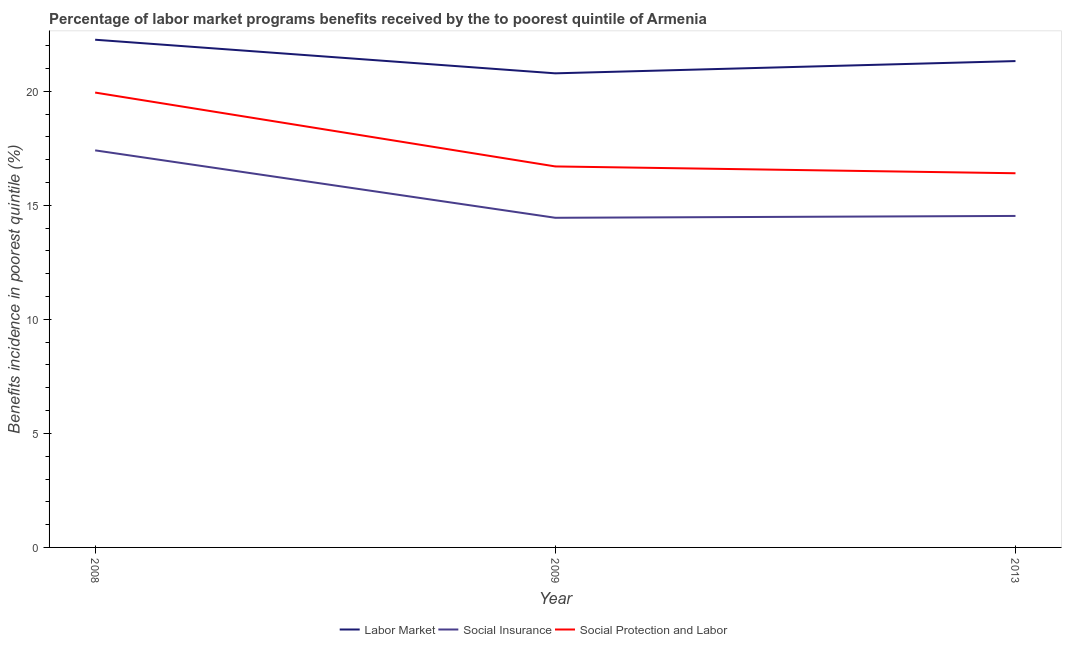How many different coloured lines are there?
Your response must be concise. 3. Does the line corresponding to percentage of benefits received due to social insurance programs intersect with the line corresponding to percentage of benefits received due to labor market programs?
Give a very brief answer. No. Is the number of lines equal to the number of legend labels?
Your answer should be very brief. Yes. What is the percentage of benefits received due to social insurance programs in 2013?
Your answer should be compact. 14.54. Across all years, what is the maximum percentage of benefits received due to labor market programs?
Your answer should be compact. 22.26. Across all years, what is the minimum percentage of benefits received due to social protection programs?
Offer a terse response. 16.41. What is the total percentage of benefits received due to social insurance programs in the graph?
Provide a short and direct response. 46.4. What is the difference between the percentage of benefits received due to social insurance programs in 2009 and that in 2013?
Ensure brevity in your answer.  -0.08. What is the difference between the percentage of benefits received due to social protection programs in 2008 and the percentage of benefits received due to social insurance programs in 2009?
Ensure brevity in your answer.  5.49. What is the average percentage of benefits received due to social protection programs per year?
Provide a short and direct response. 17.69. In the year 2013, what is the difference between the percentage of benefits received due to social protection programs and percentage of benefits received due to social insurance programs?
Offer a very short reply. 1.87. In how many years, is the percentage of benefits received due to labor market programs greater than 4 %?
Your response must be concise. 3. What is the ratio of the percentage of benefits received due to social protection programs in 2008 to that in 2009?
Ensure brevity in your answer.  1.19. Is the difference between the percentage of benefits received due to social insurance programs in 2009 and 2013 greater than the difference between the percentage of benefits received due to labor market programs in 2009 and 2013?
Keep it short and to the point. Yes. What is the difference between the highest and the second highest percentage of benefits received due to social protection programs?
Ensure brevity in your answer.  3.24. What is the difference between the highest and the lowest percentage of benefits received due to social insurance programs?
Give a very brief answer. 2.96. Is the sum of the percentage of benefits received due to social insurance programs in 2009 and 2013 greater than the maximum percentage of benefits received due to social protection programs across all years?
Provide a succinct answer. Yes. Is it the case that in every year, the sum of the percentage of benefits received due to labor market programs and percentage of benefits received due to social insurance programs is greater than the percentage of benefits received due to social protection programs?
Your answer should be very brief. Yes. Does the percentage of benefits received due to labor market programs monotonically increase over the years?
Your response must be concise. No. How many years are there in the graph?
Ensure brevity in your answer.  3. Does the graph contain any zero values?
Ensure brevity in your answer.  No. Where does the legend appear in the graph?
Offer a very short reply. Bottom center. What is the title of the graph?
Offer a terse response. Percentage of labor market programs benefits received by the to poorest quintile of Armenia. What is the label or title of the X-axis?
Offer a terse response. Year. What is the label or title of the Y-axis?
Your response must be concise. Benefits incidence in poorest quintile (%). What is the Benefits incidence in poorest quintile (%) of Labor Market in 2008?
Your response must be concise. 22.26. What is the Benefits incidence in poorest quintile (%) in Social Insurance in 2008?
Keep it short and to the point. 17.41. What is the Benefits incidence in poorest quintile (%) in Social Protection and Labor in 2008?
Offer a terse response. 19.95. What is the Benefits incidence in poorest quintile (%) in Labor Market in 2009?
Keep it short and to the point. 20.79. What is the Benefits incidence in poorest quintile (%) in Social Insurance in 2009?
Provide a short and direct response. 14.45. What is the Benefits incidence in poorest quintile (%) of Social Protection and Labor in 2009?
Offer a terse response. 16.71. What is the Benefits incidence in poorest quintile (%) in Labor Market in 2013?
Give a very brief answer. 21.33. What is the Benefits incidence in poorest quintile (%) in Social Insurance in 2013?
Your response must be concise. 14.54. What is the Benefits incidence in poorest quintile (%) of Social Protection and Labor in 2013?
Your response must be concise. 16.41. Across all years, what is the maximum Benefits incidence in poorest quintile (%) of Labor Market?
Give a very brief answer. 22.26. Across all years, what is the maximum Benefits incidence in poorest quintile (%) in Social Insurance?
Provide a succinct answer. 17.41. Across all years, what is the maximum Benefits incidence in poorest quintile (%) in Social Protection and Labor?
Provide a short and direct response. 19.95. Across all years, what is the minimum Benefits incidence in poorest quintile (%) in Labor Market?
Make the answer very short. 20.79. Across all years, what is the minimum Benefits incidence in poorest quintile (%) in Social Insurance?
Offer a very short reply. 14.45. Across all years, what is the minimum Benefits incidence in poorest quintile (%) of Social Protection and Labor?
Your response must be concise. 16.41. What is the total Benefits incidence in poorest quintile (%) in Labor Market in the graph?
Provide a succinct answer. 64.38. What is the total Benefits incidence in poorest quintile (%) in Social Insurance in the graph?
Your answer should be very brief. 46.4. What is the total Benefits incidence in poorest quintile (%) of Social Protection and Labor in the graph?
Offer a terse response. 53.06. What is the difference between the Benefits incidence in poorest quintile (%) of Labor Market in 2008 and that in 2009?
Provide a succinct answer. 1.47. What is the difference between the Benefits incidence in poorest quintile (%) in Social Insurance in 2008 and that in 2009?
Make the answer very short. 2.96. What is the difference between the Benefits incidence in poorest quintile (%) of Social Protection and Labor in 2008 and that in 2009?
Ensure brevity in your answer.  3.24. What is the difference between the Benefits incidence in poorest quintile (%) in Labor Market in 2008 and that in 2013?
Your answer should be very brief. 0.94. What is the difference between the Benefits incidence in poorest quintile (%) in Social Insurance in 2008 and that in 2013?
Provide a succinct answer. 2.88. What is the difference between the Benefits incidence in poorest quintile (%) in Social Protection and Labor in 2008 and that in 2013?
Your response must be concise. 3.54. What is the difference between the Benefits incidence in poorest quintile (%) in Labor Market in 2009 and that in 2013?
Your answer should be very brief. -0.54. What is the difference between the Benefits incidence in poorest quintile (%) of Social Insurance in 2009 and that in 2013?
Your answer should be compact. -0.08. What is the difference between the Benefits incidence in poorest quintile (%) in Social Protection and Labor in 2009 and that in 2013?
Offer a terse response. 0.3. What is the difference between the Benefits incidence in poorest quintile (%) in Labor Market in 2008 and the Benefits incidence in poorest quintile (%) in Social Insurance in 2009?
Provide a short and direct response. 7.81. What is the difference between the Benefits incidence in poorest quintile (%) in Labor Market in 2008 and the Benefits incidence in poorest quintile (%) in Social Protection and Labor in 2009?
Keep it short and to the point. 5.56. What is the difference between the Benefits incidence in poorest quintile (%) of Social Insurance in 2008 and the Benefits incidence in poorest quintile (%) of Social Protection and Labor in 2009?
Ensure brevity in your answer.  0.71. What is the difference between the Benefits incidence in poorest quintile (%) in Labor Market in 2008 and the Benefits incidence in poorest quintile (%) in Social Insurance in 2013?
Provide a succinct answer. 7.73. What is the difference between the Benefits incidence in poorest quintile (%) in Labor Market in 2008 and the Benefits incidence in poorest quintile (%) in Social Protection and Labor in 2013?
Your answer should be very brief. 5.85. What is the difference between the Benefits incidence in poorest quintile (%) of Social Insurance in 2008 and the Benefits incidence in poorest quintile (%) of Social Protection and Labor in 2013?
Provide a short and direct response. 1. What is the difference between the Benefits incidence in poorest quintile (%) of Labor Market in 2009 and the Benefits incidence in poorest quintile (%) of Social Insurance in 2013?
Offer a terse response. 6.25. What is the difference between the Benefits incidence in poorest quintile (%) of Labor Market in 2009 and the Benefits incidence in poorest quintile (%) of Social Protection and Labor in 2013?
Keep it short and to the point. 4.38. What is the difference between the Benefits incidence in poorest quintile (%) of Social Insurance in 2009 and the Benefits incidence in poorest quintile (%) of Social Protection and Labor in 2013?
Your response must be concise. -1.95. What is the average Benefits incidence in poorest quintile (%) of Labor Market per year?
Your answer should be compact. 21.46. What is the average Benefits incidence in poorest quintile (%) in Social Insurance per year?
Offer a terse response. 15.47. What is the average Benefits incidence in poorest quintile (%) of Social Protection and Labor per year?
Your response must be concise. 17.69. In the year 2008, what is the difference between the Benefits incidence in poorest quintile (%) in Labor Market and Benefits incidence in poorest quintile (%) in Social Insurance?
Offer a terse response. 4.85. In the year 2008, what is the difference between the Benefits incidence in poorest quintile (%) in Labor Market and Benefits incidence in poorest quintile (%) in Social Protection and Labor?
Provide a succinct answer. 2.32. In the year 2008, what is the difference between the Benefits incidence in poorest quintile (%) in Social Insurance and Benefits incidence in poorest quintile (%) in Social Protection and Labor?
Offer a terse response. -2.53. In the year 2009, what is the difference between the Benefits incidence in poorest quintile (%) in Labor Market and Benefits incidence in poorest quintile (%) in Social Insurance?
Offer a very short reply. 6.33. In the year 2009, what is the difference between the Benefits incidence in poorest quintile (%) of Labor Market and Benefits incidence in poorest quintile (%) of Social Protection and Labor?
Ensure brevity in your answer.  4.08. In the year 2009, what is the difference between the Benefits incidence in poorest quintile (%) in Social Insurance and Benefits incidence in poorest quintile (%) in Social Protection and Labor?
Offer a terse response. -2.25. In the year 2013, what is the difference between the Benefits incidence in poorest quintile (%) in Labor Market and Benefits incidence in poorest quintile (%) in Social Insurance?
Your answer should be very brief. 6.79. In the year 2013, what is the difference between the Benefits incidence in poorest quintile (%) of Labor Market and Benefits incidence in poorest quintile (%) of Social Protection and Labor?
Provide a succinct answer. 4.92. In the year 2013, what is the difference between the Benefits incidence in poorest quintile (%) of Social Insurance and Benefits incidence in poorest quintile (%) of Social Protection and Labor?
Provide a succinct answer. -1.87. What is the ratio of the Benefits incidence in poorest quintile (%) of Labor Market in 2008 to that in 2009?
Provide a succinct answer. 1.07. What is the ratio of the Benefits incidence in poorest quintile (%) in Social Insurance in 2008 to that in 2009?
Provide a succinct answer. 1.2. What is the ratio of the Benefits incidence in poorest quintile (%) in Social Protection and Labor in 2008 to that in 2009?
Offer a very short reply. 1.19. What is the ratio of the Benefits incidence in poorest quintile (%) in Labor Market in 2008 to that in 2013?
Your response must be concise. 1.04. What is the ratio of the Benefits incidence in poorest quintile (%) in Social Insurance in 2008 to that in 2013?
Offer a very short reply. 1.2. What is the ratio of the Benefits incidence in poorest quintile (%) in Social Protection and Labor in 2008 to that in 2013?
Ensure brevity in your answer.  1.22. What is the ratio of the Benefits incidence in poorest quintile (%) in Labor Market in 2009 to that in 2013?
Provide a succinct answer. 0.97. What is the ratio of the Benefits incidence in poorest quintile (%) of Social Insurance in 2009 to that in 2013?
Provide a short and direct response. 0.99. What is the ratio of the Benefits incidence in poorest quintile (%) in Social Protection and Labor in 2009 to that in 2013?
Make the answer very short. 1.02. What is the difference between the highest and the second highest Benefits incidence in poorest quintile (%) in Labor Market?
Your response must be concise. 0.94. What is the difference between the highest and the second highest Benefits incidence in poorest quintile (%) of Social Insurance?
Provide a succinct answer. 2.88. What is the difference between the highest and the second highest Benefits incidence in poorest quintile (%) in Social Protection and Labor?
Your response must be concise. 3.24. What is the difference between the highest and the lowest Benefits incidence in poorest quintile (%) in Labor Market?
Give a very brief answer. 1.47. What is the difference between the highest and the lowest Benefits incidence in poorest quintile (%) of Social Insurance?
Your answer should be very brief. 2.96. What is the difference between the highest and the lowest Benefits incidence in poorest quintile (%) in Social Protection and Labor?
Provide a succinct answer. 3.54. 